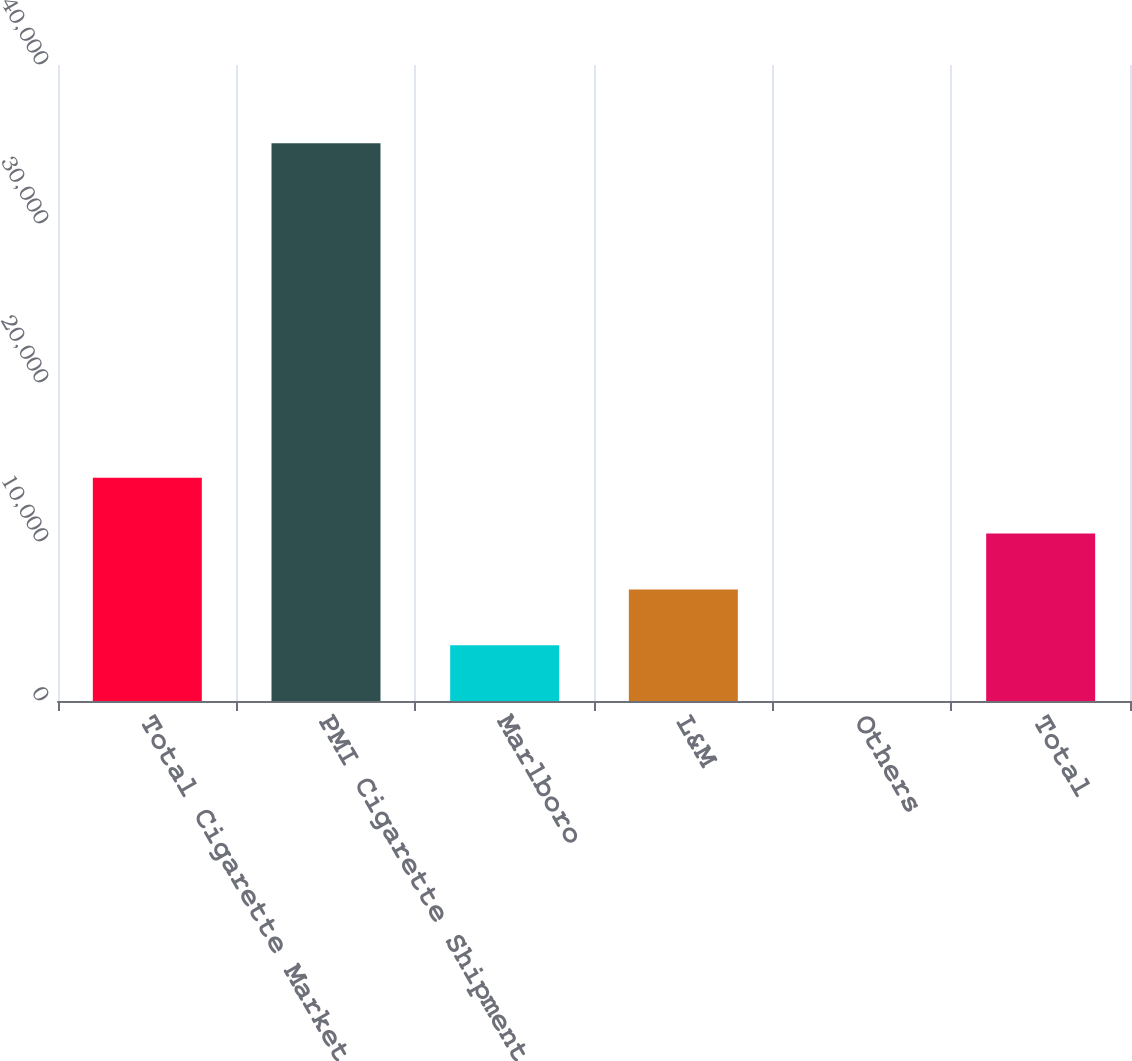<chart> <loc_0><loc_0><loc_500><loc_500><bar_chart><fcel>Total Cigarette Market<fcel>PMI Cigarette Shipments<fcel>Marlboro<fcel>L&M<fcel>Others<fcel>Total<nl><fcel>14035.7<fcel>35085<fcel>3511.11<fcel>7019.32<fcel>2.9<fcel>10527.5<nl></chart> 